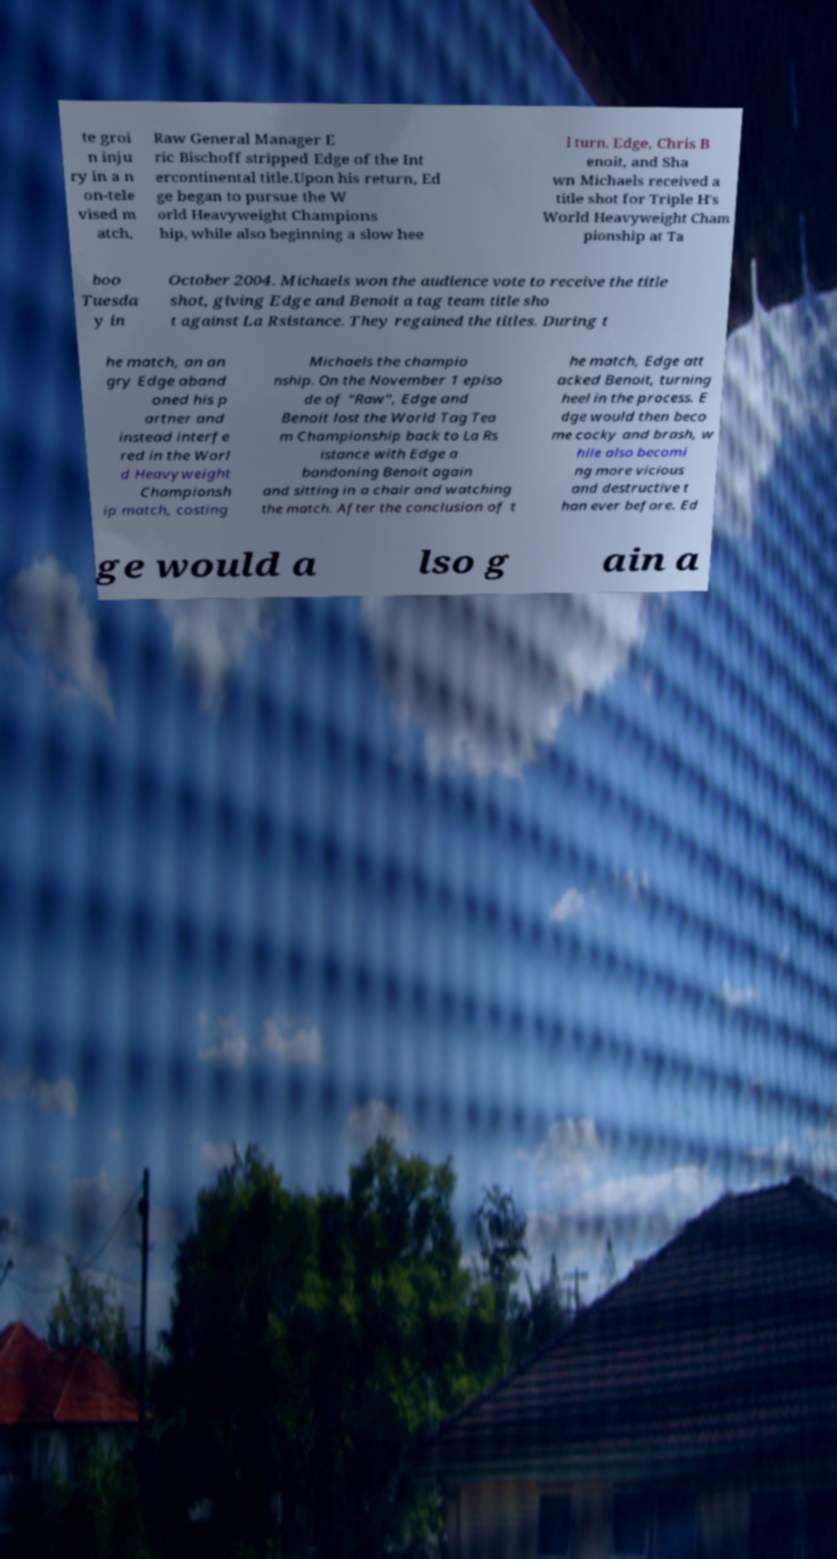I need the written content from this picture converted into text. Can you do that? te groi n inju ry in a n on-tele vised m atch, Raw General Manager E ric Bischoff stripped Edge of the Int ercontinental title.Upon his return, Ed ge began to pursue the W orld Heavyweight Champions hip, while also beginning a slow hee l turn. Edge, Chris B enoit, and Sha wn Michaels received a title shot for Triple H's World Heavyweight Cham pionship at Ta boo Tuesda y in October 2004. Michaels won the audience vote to receive the title shot, giving Edge and Benoit a tag team title sho t against La Rsistance. They regained the titles. During t he match, an an gry Edge aband oned his p artner and instead interfe red in the Worl d Heavyweight Championsh ip match, costing Michaels the champio nship. On the November 1 episo de of "Raw", Edge and Benoit lost the World Tag Tea m Championship back to La Rs istance with Edge a bandoning Benoit again and sitting in a chair and watching the match. After the conclusion of t he match, Edge att acked Benoit, turning heel in the process. E dge would then beco me cocky and brash, w hile also becomi ng more vicious and destructive t han ever before. Ed ge would a lso g ain a 